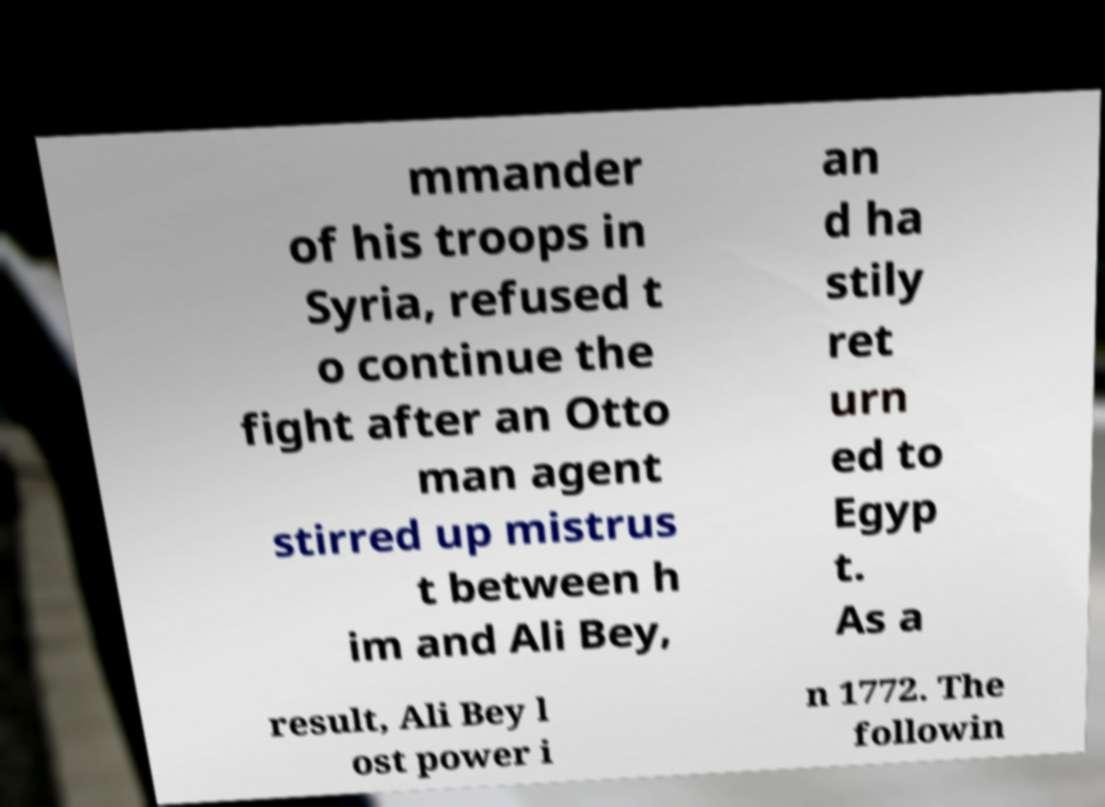Can you read and provide the text displayed in the image?This photo seems to have some interesting text. Can you extract and type it out for me? mmander of his troops in Syria, refused t o continue the fight after an Otto man agent stirred up mistrus t between h im and Ali Bey, an d ha stily ret urn ed to Egyp t. As a result, Ali Bey l ost power i n 1772. The followin 